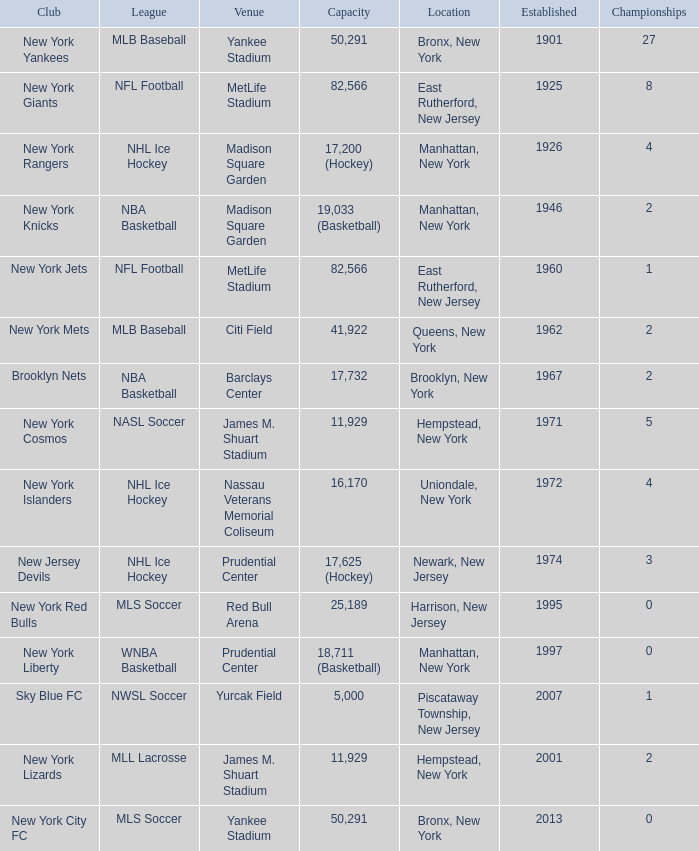When was the venue named nassau veterans memorial coliseum established?? 1972.0. 